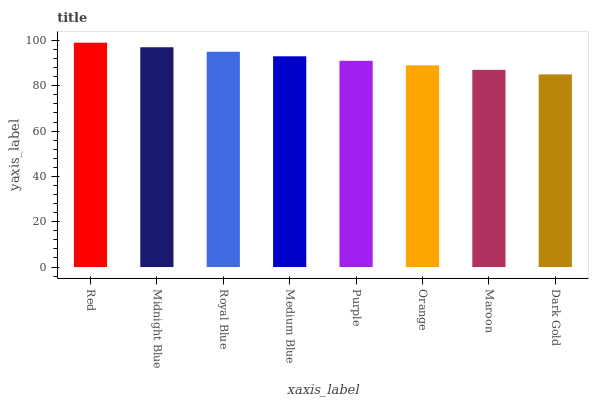Is Dark Gold the minimum?
Answer yes or no. Yes. Is Red the maximum?
Answer yes or no. Yes. Is Midnight Blue the minimum?
Answer yes or no. No. Is Midnight Blue the maximum?
Answer yes or no. No. Is Red greater than Midnight Blue?
Answer yes or no. Yes. Is Midnight Blue less than Red?
Answer yes or no. Yes. Is Midnight Blue greater than Red?
Answer yes or no. No. Is Red less than Midnight Blue?
Answer yes or no. No. Is Medium Blue the high median?
Answer yes or no. Yes. Is Purple the low median?
Answer yes or no. Yes. Is Royal Blue the high median?
Answer yes or no. No. Is Royal Blue the low median?
Answer yes or no. No. 